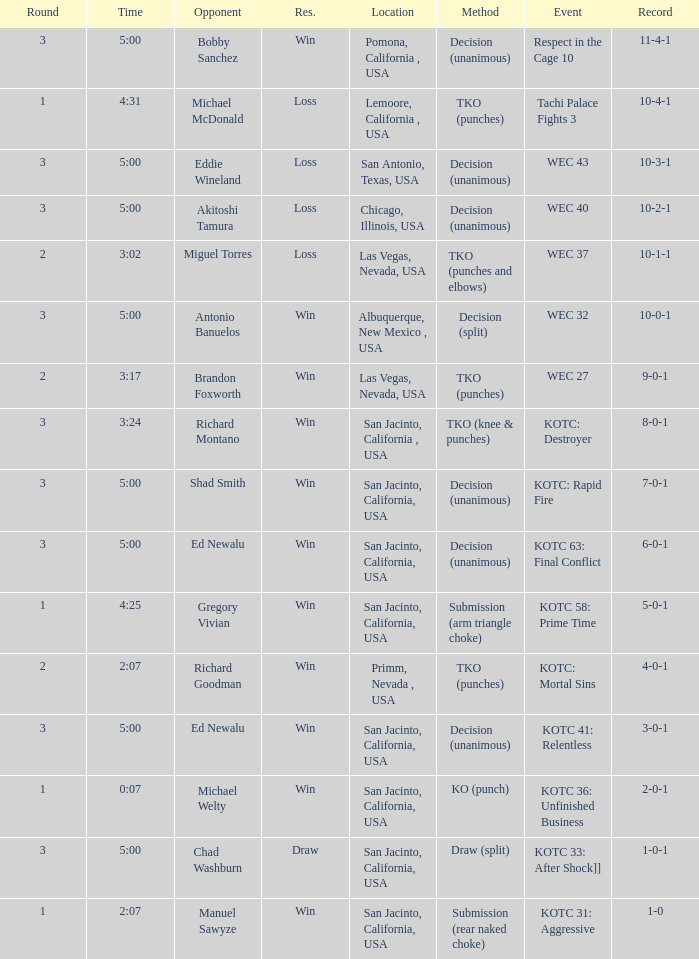What location did the event kotc: mortal sins take place? Primm, Nevada , USA. 